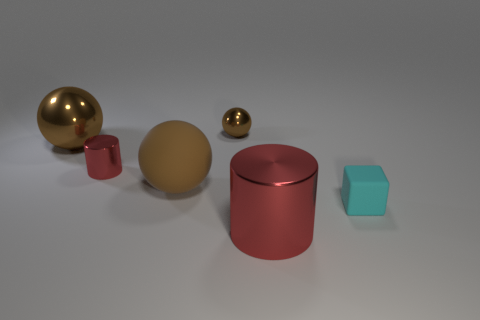How many brown balls must be subtracted to get 1 brown balls? 2 Subtract all large brown spheres. How many spheres are left? 1 Subtract 2 cylinders. How many cylinders are left? 0 Subtract all blocks. How many objects are left? 5 Add 2 gray rubber cubes. How many objects exist? 8 Subtract all tiny brown shiny spheres. Subtract all red cylinders. How many objects are left? 3 Add 3 balls. How many balls are left? 6 Add 5 small cubes. How many small cubes exist? 6 Subtract 0 brown cylinders. How many objects are left? 6 Subtract all purple cubes. Subtract all brown spheres. How many cubes are left? 1 